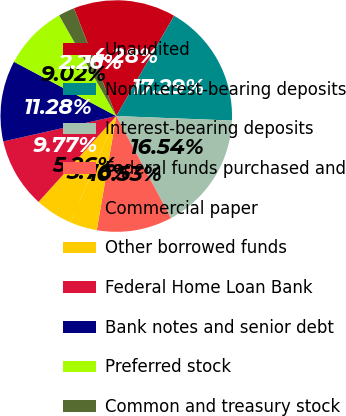Convert chart to OTSL. <chart><loc_0><loc_0><loc_500><loc_500><pie_chart><fcel>Unaudited<fcel>Noninterest-bearing deposits<fcel>Interest-bearing deposits<fcel>Federal funds purchased and<fcel>Commercial paper<fcel>Other borrowed funds<fcel>Federal Home Loan Bank<fcel>Bank notes and senior debt<fcel>Preferred stock<fcel>Common and treasury stock<nl><fcel>14.28%<fcel>17.29%<fcel>16.54%<fcel>10.53%<fcel>3.76%<fcel>5.26%<fcel>9.77%<fcel>11.28%<fcel>9.02%<fcel>2.26%<nl></chart> 